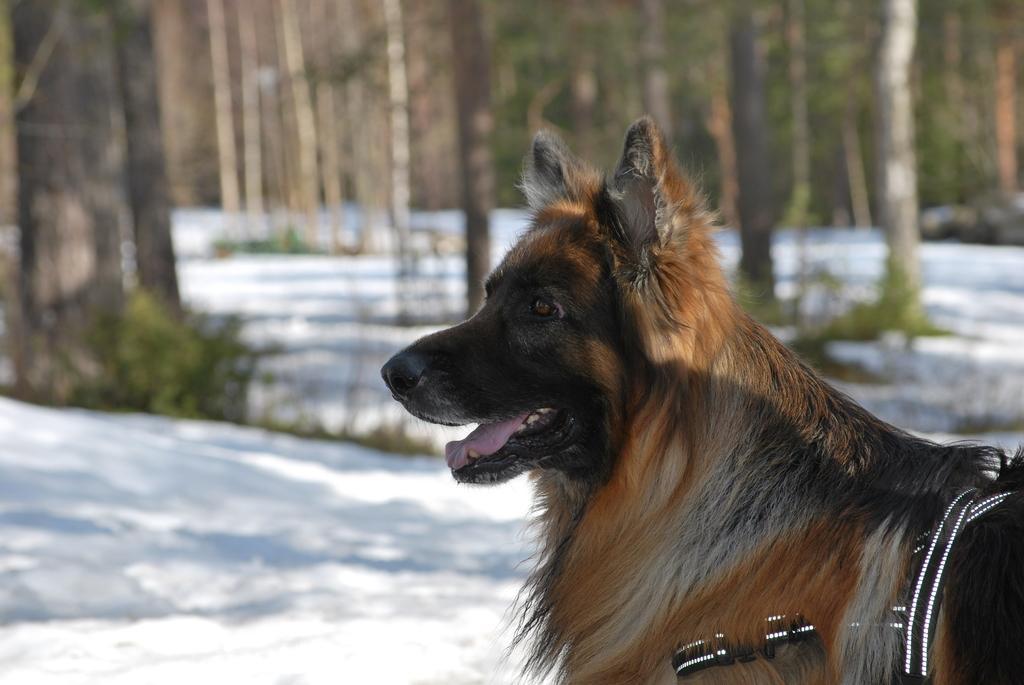Can you describe this image briefly? This image is taken outdoors. In the background there are many trees and a few plants. At the bottom of the image there is a ground covered with snow. On the right side of the image there is a dog on the ground. 